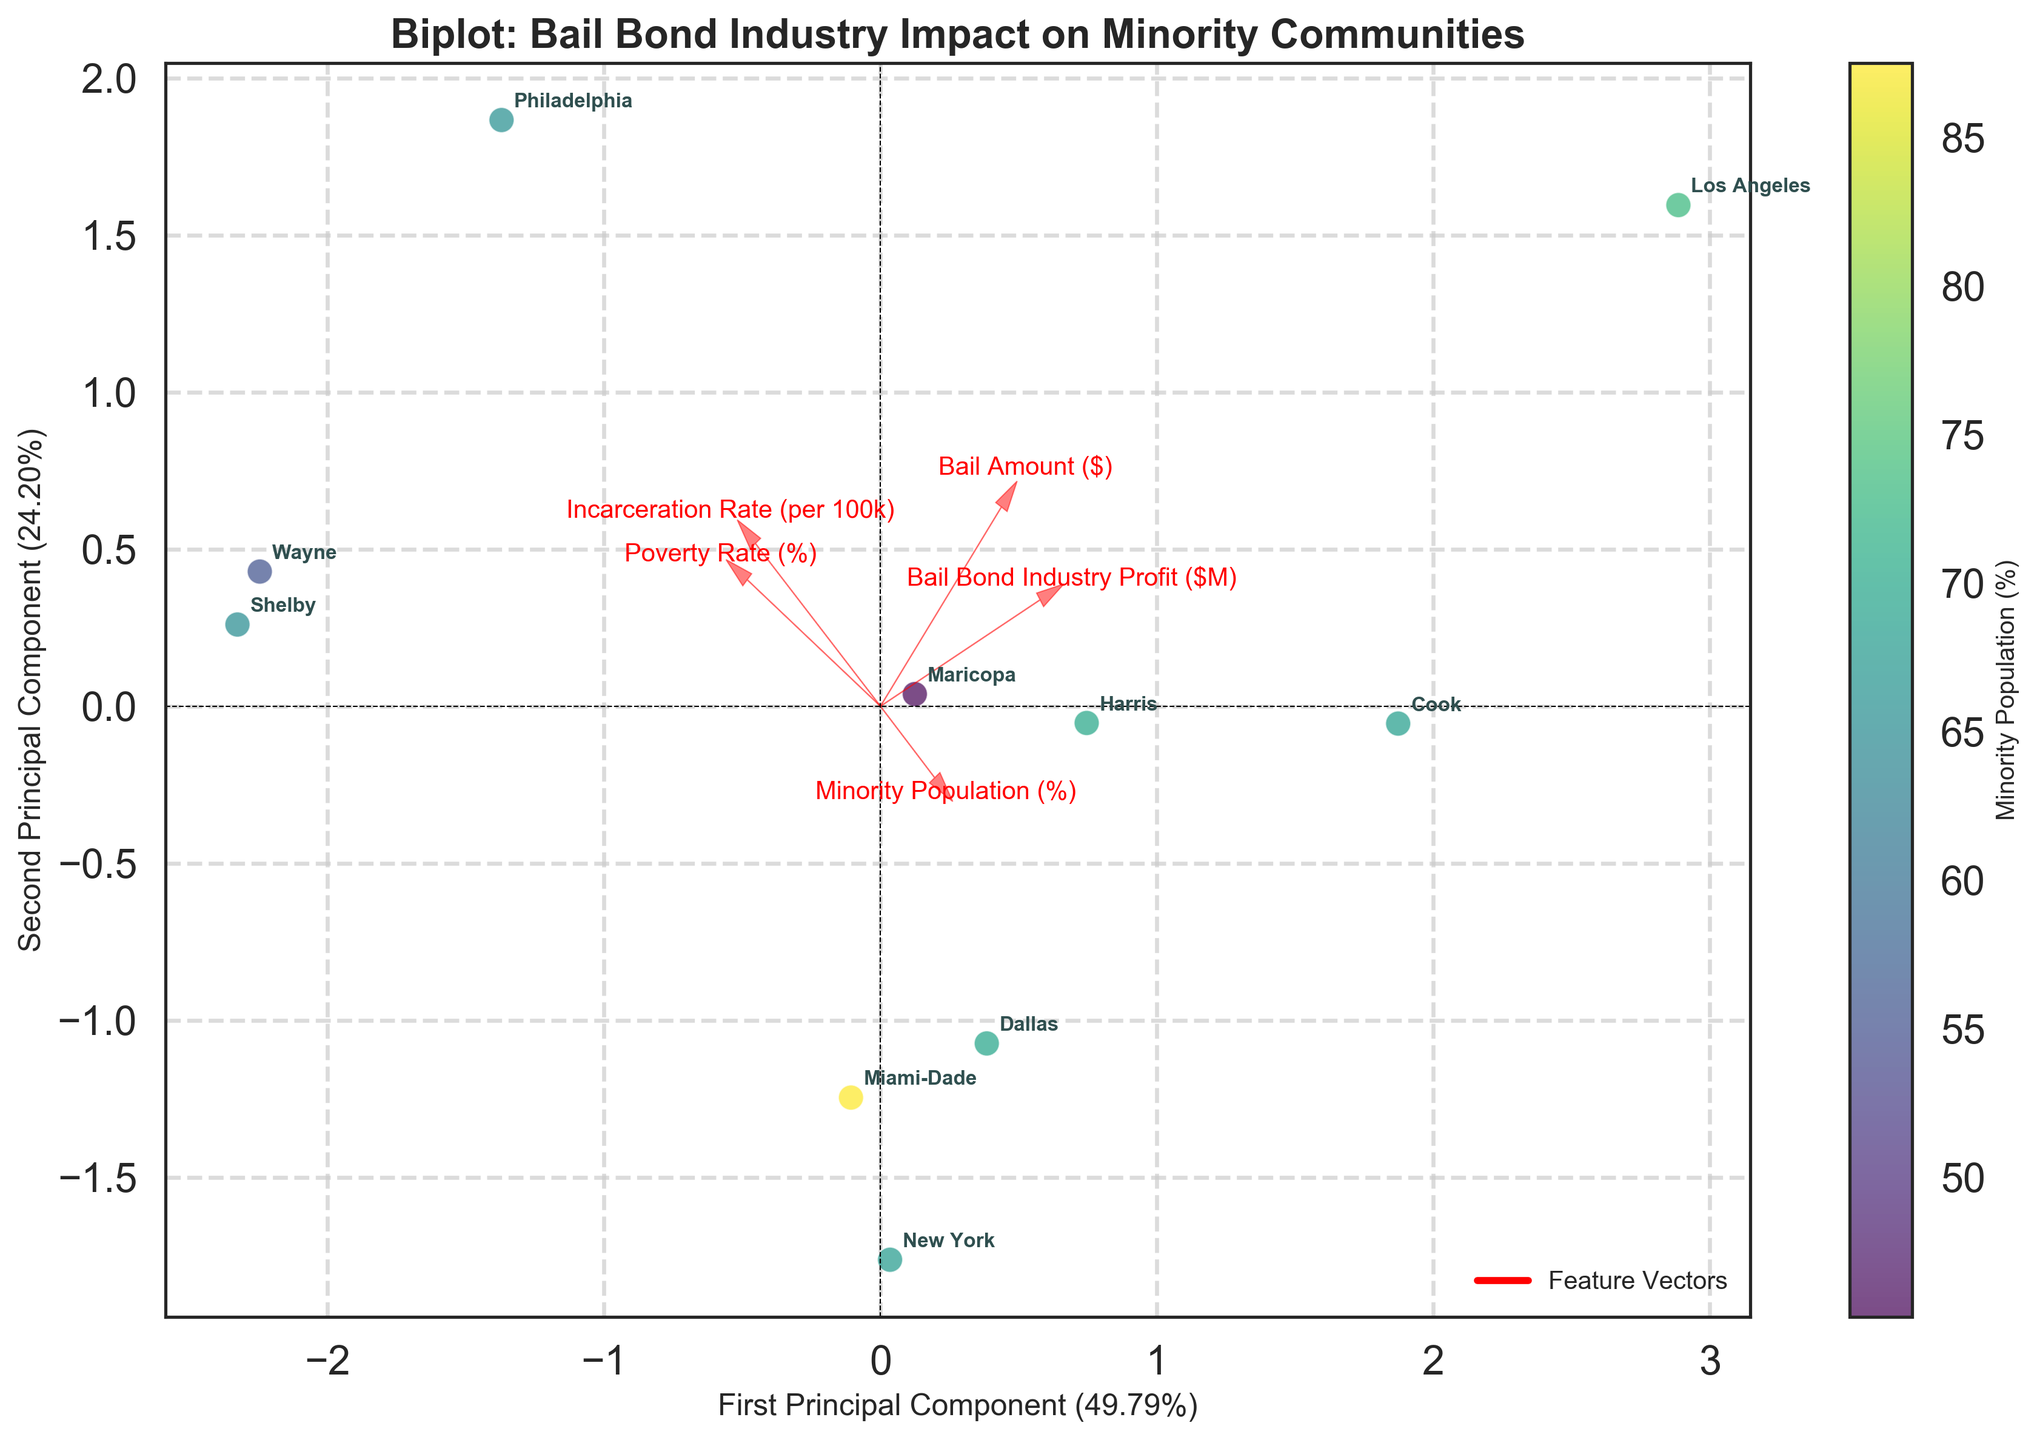Who has the highest minority population percentage? Look at the color intensity of the data points, Miami-Dade has the most intense color, indicating the highest minority population percentage at 87.5%.
Answer: Miami-Dade Which county has the highest incarceration rate? Check the axis correlation; Shelby sits furthest along the axis corresponding to the incarceration rate arrow, indicating its highest rate at 892 per 100k.
Answer: Shelby How does the 'Bail Bond Industry Profit' vector relate to the other features? The arrow for 'Bail Bond Industry Profit' shows its relationship direction with the other features. It points in a similar direction to the 'Incarceration Rate', indicating a positive correlation and in a different direction from 'Minority Population (%)' and 'Bail Amount ($)', suggesting a negative or weaker correlation.
Answer: Positively with 'Incarceration Rate', negatively or weakly with 'Minority Population (%)' and 'Bail Amount ($)' Which county has the lowest bail amount? Look for the data point closest to where the 'Bail Amount ($)' vector points in the negative direction. New York and Wayne have the lowest bail amount at $5000.
Answer: New York & Wayne What is the relationship between 'Poverty Rate' and 'Incarceration Rate'? Examine the angle between the vectors associated with 'Poverty Rate (%)' and 'Incarceration Rate (per 100k)'. They point in similar directions, implying a positive relationship.
Answer: Positive relationship Which county has the lowest bail bond industry profit and what is its incarceration rate? The point closest to the origin of the first principal component with the label 'New York' represents the smallest bail bond profit at $36M. It has an incarceration rate at 376 per 100k.
Answer: New York, 376 per 100k What percentage of variance do the first two principal components explain together? Add the explained variance percentages mentioned on the x and y axes of the biplot. The first principal component explains 37.6% and the second 30.4%, adding up to 68%.
Answer: 68% Name a county that has a high incarceration rate but a low bail amount. Shelby has a high incarceration rate at 892 per 100k, indicated by its location along the incarceration rate vector. Its bail amount is $2500, one of the lower amounts indicated by its orientation near the 'Bail Amount ($)' vector's direction.
Answer: Shelby Which counties align closely with both high poverty rate and high incarceration rate vectors? Identify the points positioned where 'Poverty Rate' and 'Incarceration Rate' vectors cluster. Philadelphia and Wayne lie in this region, indicating high values for both features.
Answer: Philadelphia & Wayne 